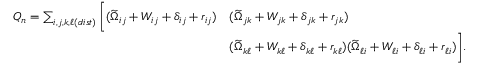Convert formula to latex. <formula><loc_0><loc_0><loc_500><loc_500>\begin{array} { r l } { Q _ { n } = \sum _ { i , j , k , \ell ( d i s t ) } \left [ ( \widetilde { \Omega } _ { i j } + W _ { i j } + \delta _ { i j } + r _ { i j } ) } & { ( \widetilde { \Omega } _ { j k } + W _ { j k } + \delta _ { j k } + r _ { j k } ) } \\ & { ( \widetilde { \Omega } _ { k \ell } + W _ { k \ell } + \delta _ { k \ell } + r _ { k \ell } ) ( \widetilde { \Omega } _ { \ell i } + W _ { \ell i } + \delta _ { \ell i } + r _ { \ell i } ) \right ] . } \end{array}</formula> 